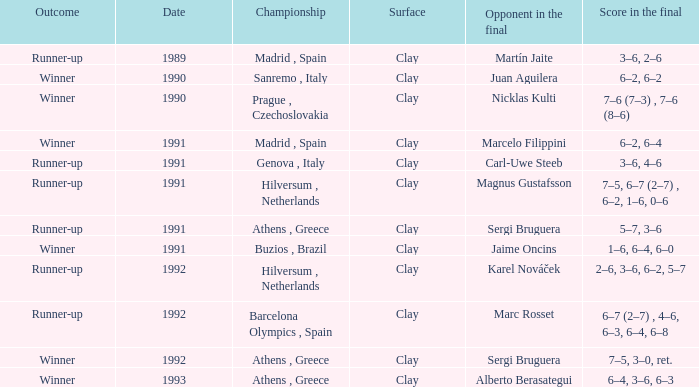What is the adversary in the final, when the date is prior to 1991, and the outcome is "runner-up"? Martín Jaite. 